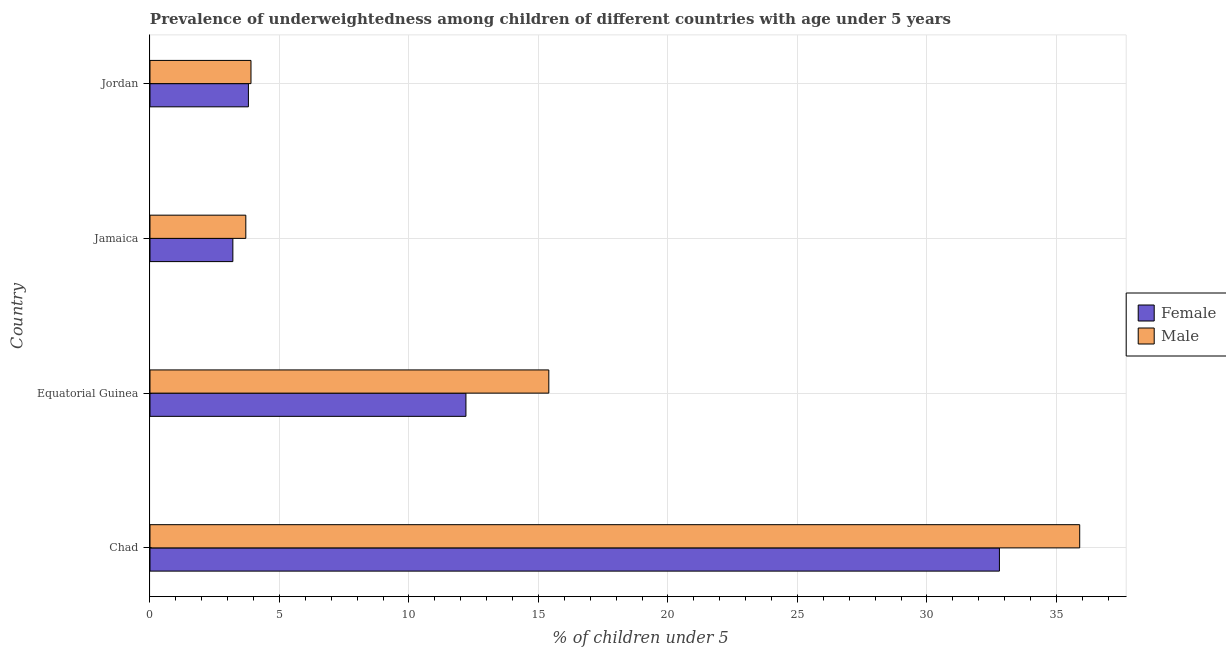How many groups of bars are there?
Give a very brief answer. 4. Are the number of bars per tick equal to the number of legend labels?
Ensure brevity in your answer.  Yes. How many bars are there on the 3rd tick from the top?
Make the answer very short. 2. What is the label of the 4th group of bars from the top?
Ensure brevity in your answer.  Chad. What is the percentage of underweighted female children in Equatorial Guinea?
Provide a succinct answer. 12.2. Across all countries, what is the maximum percentage of underweighted male children?
Offer a very short reply. 35.9. Across all countries, what is the minimum percentage of underweighted male children?
Your response must be concise. 3.7. In which country was the percentage of underweighted male children maximum?
Your answer should be compact. Chad. In which country was the percentage of underweighted female children minimum?
Ensure brevity in your answer.  Jamaica. What is the total percentage of underweighted male children in the graph?
Ensure brevity in your answer.  58.9. What is the difference between the percentage of underweighted male children in Equatorial Guinea and that in Jordan?
Your answer should be compact. 11.5. What is the difference between the percentage of underweighted female children in Chad and the percentage of underweighted male children in Jordan?
Your answer should be very brief. 28.9. What is the average percentage of underweighted male children per country?
Make the answer very short. 14.72. What is the difference between the percentage of underweighted male children and percentage of underweighted female children in Jordan?
Your answer should be compact. 0.1. What is the ratio of the percentage of underweighted male children in Jamaica to that in Jordan?
Provide a succinct answer. 0.95. What is the difference between the highest and the second highest percentage of underweighted male children?
Make the answer very short. 20.5. What is the difference between the highest and the lowest percentage of underweighted male children?
Keep it short and to the point. 32.2. In how many countries, is the percentage of underweighted female children greater than the average percentage of underweighted female children taken over all countries?
Your answer should be compact. 1. Is the sum of the percentage of underweighted female children in Equatorial Guinea and Jamaica greater than the maximum percentage of underweighted male children across all countries?
Your response must be concise. No. What does the 1st bar from the bottom in Jordan represents?
Keep it short and to the point. Female. How many bars are there?
Ensure brevity in your answer.  8. Are all the bars in the graph horizontal?
Provide a short and direct response. Yes. What is the difference between two consecutive major ticks on the X-axis?
Your response must be concise. 5. Does the graph contain any zero values?
Keep it short and to the point. No. Does the graph contain grids?
Provide a short and direct response. Yes. Where does the legend appear in the graph?
Your answer should be compact. Center right. How are the legend labels stacked?
Your response must be concise. Vertical. What is the title of the graph?
Provide a succinct answer. Prevalence of underweightedness among children of different countries with age under 5 years. Does "Highest 20% of population" appear as one of the legend labels in the graph?
Keep it short and to the point. No. What is the label or title of the X-axis?
Your response must be concise.  % of children under 5. What is the  % of children under 5 of Female in Chad?
Make the answer very short. 32.8. What is the  % of children under 5 of Male in Chad?
Make the answer very short. 35.9. What is the  % of children under 5 of Female in Equatorial Guinea?
Your answer should be compact. 12.2. What is the  % of children under 5 in Male in Equatorial Guinea?
Make the answer very short. 15.4. What is the  % of children under 5 of Female in Jamaica?
Give a very brief answer. 3.2. What is the  % of children under 5 of Male in Jamaica?
Make the answer very short. 3.7. What is the  % of children under 5 of Female in Jordan?
Keep it short and to the point. 3.8. What is the  % of children under 5 in Male in Jordan?
Offer a terse response. 3.9. Across all countries, what is the maximum  % of children under 5 of Female?
Make the answer very short. 32.8. Across all countries, what is the maximum  % of children under 5 in Male?
Your answer should be very brief. 35.9. Across all countries, what is the minimum  % of children under 5 of Female?
Offer a terse response. 3.2. Across all countries, what is the minimum  % of children under 5 of Male?
Offer a terse response. 3.7. What is the total  % of children under 5 in Female in the graph?
Offer a very short reply. 52. What is the total  % of children under 5 in Male in the graph?
Your answer should be very brief. 58.9. What is the difference between the  % of children under 5 in Female in Chad and that in Equatorial Guinea?
Provide a succinct answer. 20.6. What is the difference between the  % of children under 5 in Female in Chad and that in Jamaica?
Your answer should be compact. 29.6. What is the difference between the  % of children under 5 in Male in Chad and that in Jamaica?
Offer a terse response. 32.2. What is the difference between the  % of children under 5 of Female in Chad and that in Jordan?
Ensure brevity in your answer.  29. What is the difference between the  % of children under 5 of Male in Chad and that in Jordan?
Ensure brevity in your answer.  32. What is the difference between the  % of children under 5 in Male in Equatorial Guinea and that in Jamaica?
Keep it short and to the point. 11.7. What is the difference between the  % of children under 5 of Male in Jamaica and that in Jordan?
Provide a short and direct response. -0.2. What is the difference between the  % of children under 5 of Female in Chad and the  % of children under 5 of Male in Jamaica?
Keep it short and to the point. 29.1. What is the difference between the  % of children under 5 in Female in Chad and the  % of children under 5 in Male in Jordan?
Provide a succinct answer. 28.9. What is the difference between the  % of children under 5 of Female in Equatorial Guinea and the  % of children under 5 of Male in Jordan?
Offer a very short reply. 8.3. What is the average  % of children under 5 in Female per country?
Your answer should be compact. 13. What is the average  % of children under 5 of Male per country?
Your answer should be compact. 14.72. What is the difference between the  % of children under 5 in Female and  % of children under 5 in Male in Equatorial Guinea?
Your answer should be compact. -3.2. What is the difference between the  % of children under 5 of Female and  % of children under 5 of Male in Jamaica?
Offer a very short reply. -0.5. What is the difference between the  % of children under 5 of Female and  % of children under 5 of Male in Jordan?
Your answer should be compact. -0.1. What is the ratio of the  % of children under 5 of Female in Chad to that in Equatorial Guinea?
Give a very brief answer. 2.69. What is the ratio of the  % of children under 5 in Male in Chad to that in Equatorial Guinea?
Your response must be concise. 2.33. What is the ratio of the  % of children under 5 in Female in Chad to that in Jamaica?
Offer a terse response. 10.25. What is the ratio of the  % of children under 5 in Male in Chad to that in Jamaica?
Your answer should be very brief. 9.7. What is the ratio of the  % of children under 5 of Female in Chad to that in Jordan?
Your answer should be very brief. 8.63. What is the ratio of the  % of children under 5 of Male in Chad to that in Jordan?
Your answer should be very brief. 9.21. What is the ratio of the  % of children under 5 of Female in Equatorial Guinea to that in Jamaica?
Offer a very short reply. 3.81. What is the ratio of the  % of children under 5 of Male in Equatorial Guinea to that in Jamaica?
Offer a very short reply. 4.16. What is the ratio of the  % of children under 5 in Female in Equatorial Guinea to that in Jordan?
Provide a short and direct response. 3.21. What is the ratio of the  % of children under 5 of Male in Equatorial Guinea to that in Jordan?
Provide a short and direct response. 3.95. What is the ratio of the  % of children under 5 of Female in Jamaica to that in Jordan?
Your response must be concise. 0.84. What is the ratio of the  % of children under 5 in Male in Jamaica to that in Jordan?
Provide a short and direct response. 0.95. What is the difference between the highest and the second highest  % of children under 5 of Female?
Provide a succinct answer. 20.6. What is the difference between the highest and the second highest  % of children under 5 in Male?
Your response must be concise. 20.5. What is the difference between the highest and the lowest  % of children under 5 of Female?
Provide a short and direct response. 29.6. What is the difference between the highest and the lowest  % of children under 5 in Male?
Your answer should be compact. 32.2. 